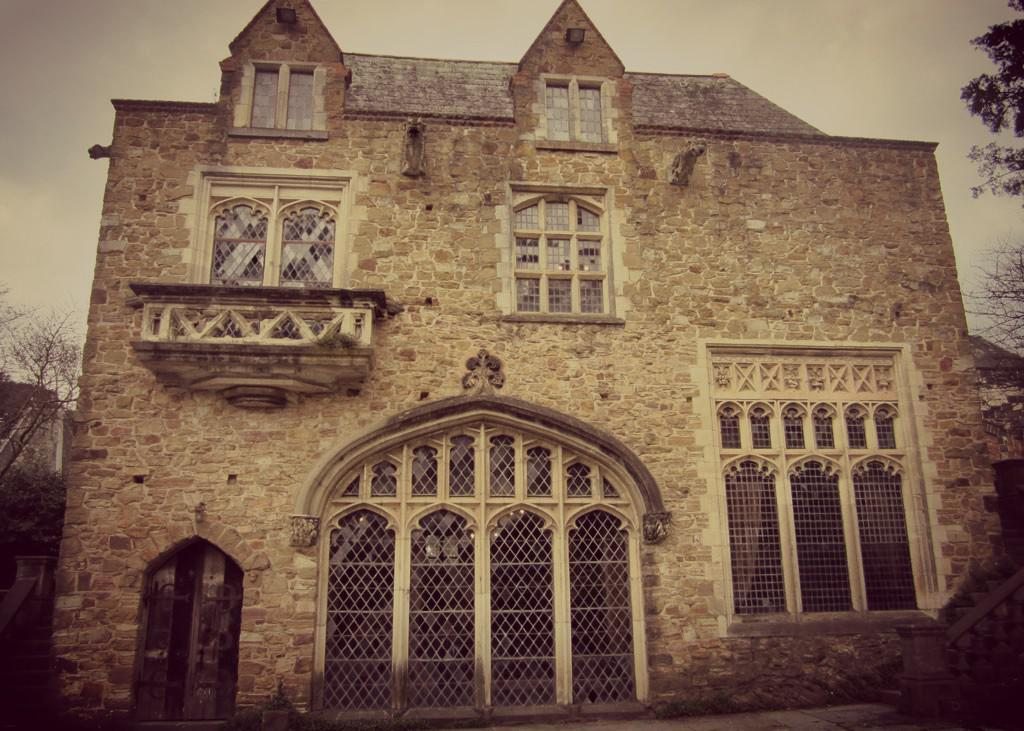What is the main subject in the foreground of the image? There is a building in the foreground of the image. What can be seen on either side of the building? There are trees on either side of the building. What is visible at the top of the image? The sky is visible at the top of the image. Where is the girl standing with her umbrella in the image? There is no girl or umbrella present in the image. 